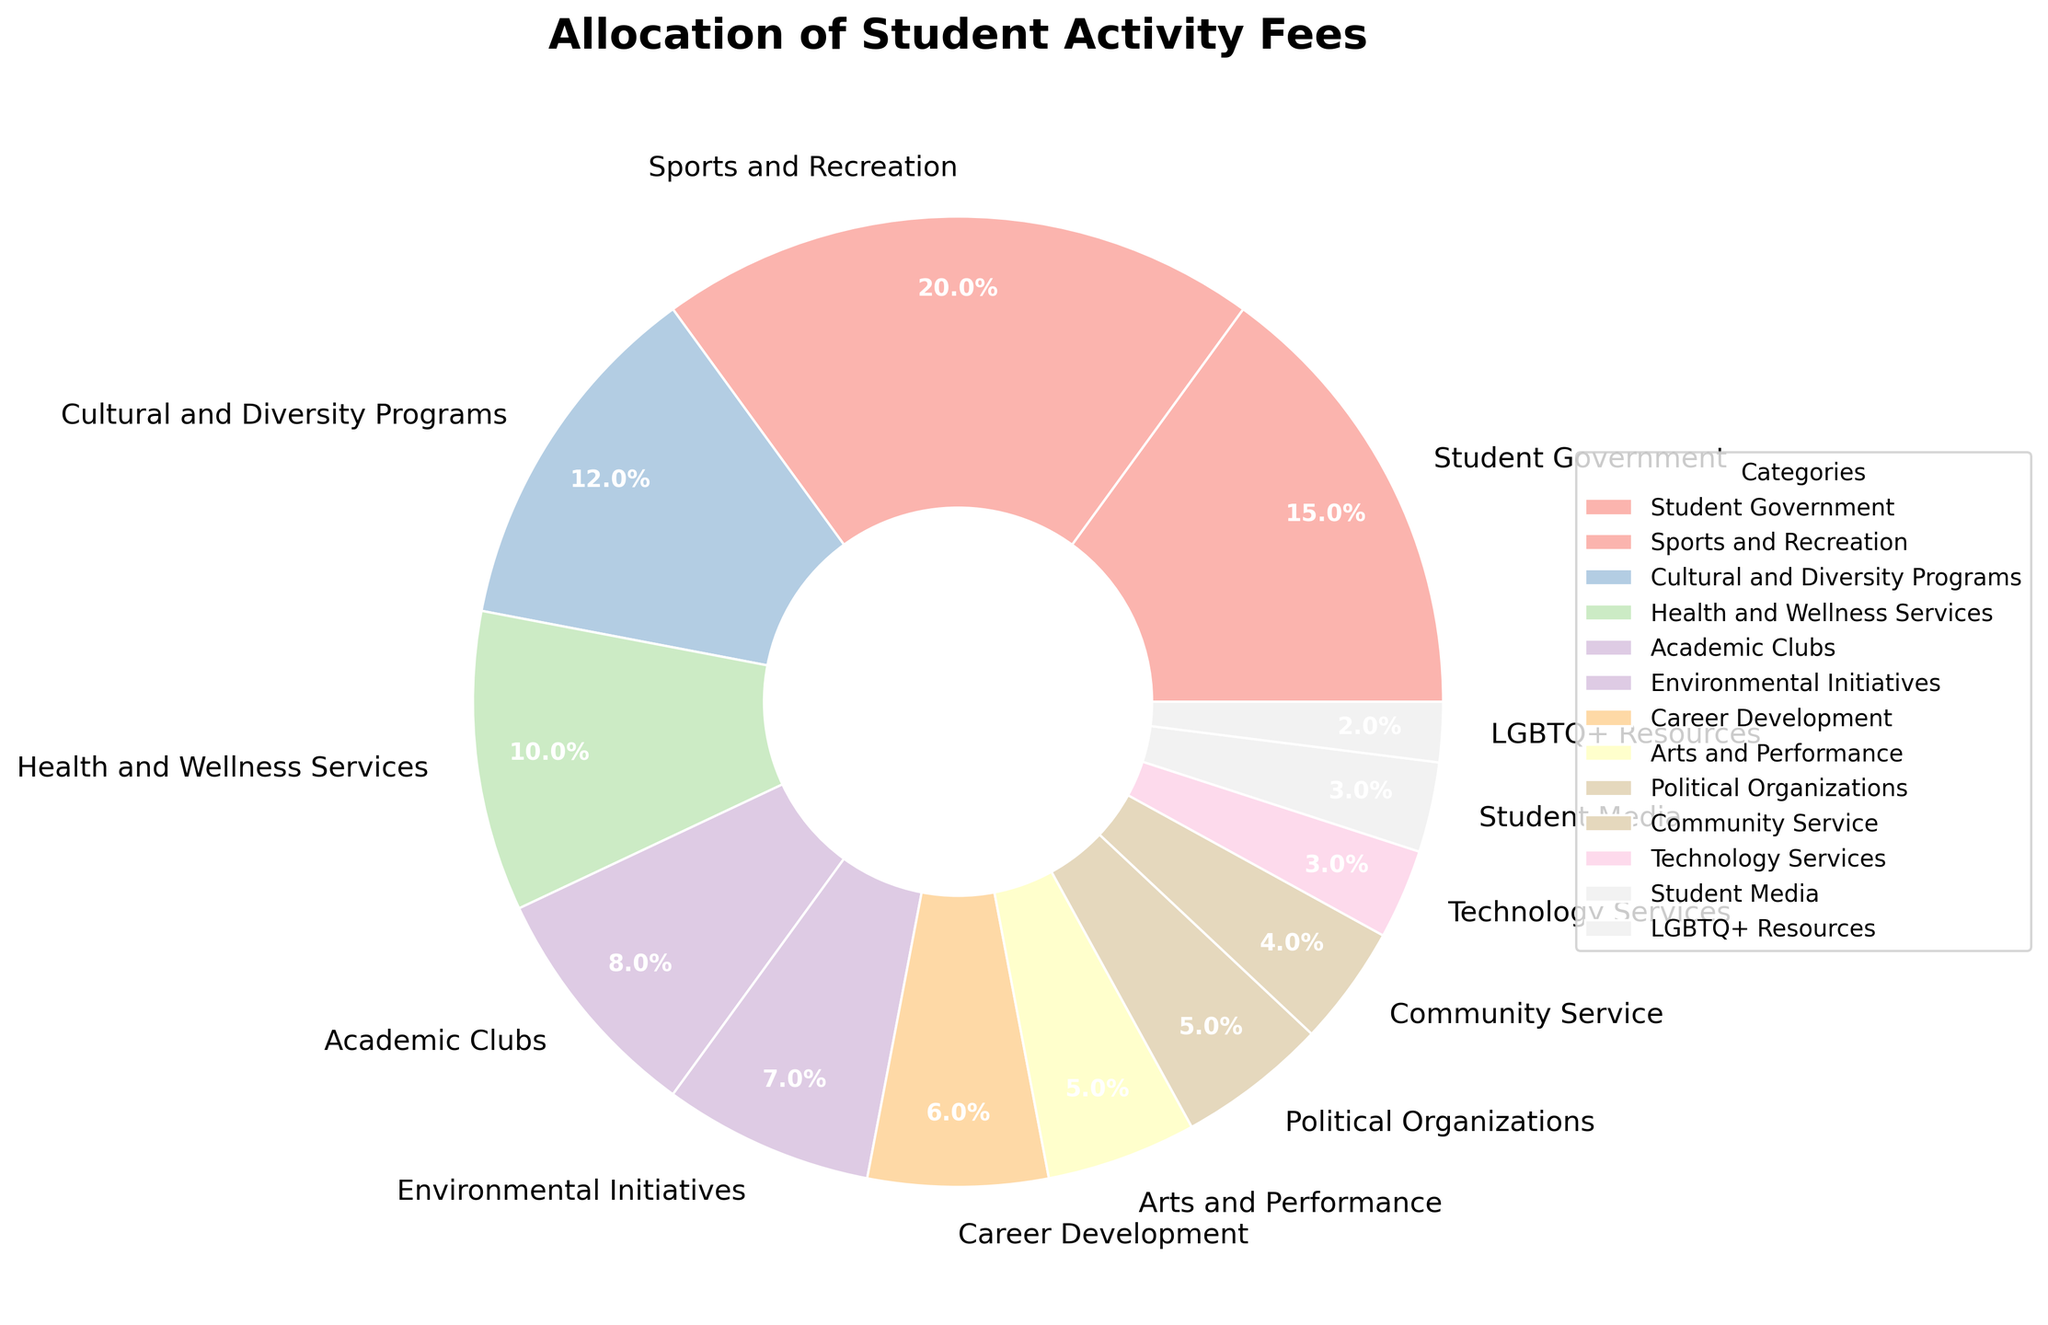Which category receives the highest percentage of student activity fees? The figure shows a pie chart with various categories and their respective percentages. The largest segment belongs to "Sports and Recreation" with 20%.
Answer: Sports and Recreation What is the total percentage allocated to Academic Clubs and Environmental Initiatives combined? To find the combined percentage, add the percentage values from both categories: Academic Clubs (8%) + Environmental Initiatives (7%) = 15%.
Answer: 15% How does the allocation for Political Organizations compare to that for Career Development? The pie chart shows Political Organizations at 5% and Career Development at 6%. Hence, Career Development receives a higher percentage by 1%.
Answer: Career Development is higher Which category has the smallest allocation, and what is its percentage? The smallest segment in the pie chart belongs to "LGBTQ+ Resources" with 2%.
Answer: LGBTQ+ Resources, 2% What is the difference in percentage between Sports and Recreation and Arts and Performance? Subtract the percentage for Arts and Performance (5%) from that for Sports and Recreation (20%): 20% - 5% = 15%.
Answer: 15% What percentage of the student activity fees is allocated to categories related to student welfare services (Health and Wellness Services + LGBTQ+ Resources)? Sum the percentages: Health and Wellness Services (10%) + LGBTQ+ Resources (2%) = 12%.
Answer: 12% Which categories have an equal allocation percentage? From the pie chart, Arts and Performance and Political Organizations both have an allocation of 5%.
Answer: Arts and Performance and Political Organizations What is the combined percentage of categories receiving less than 5% of the student activity fees? Add the percentages of Community Service (4%), Technology Services (3%), Student Media (3%), and LGBTQ+ Resources (2%): 4% + 3% + 3% + 2% = 12%.
Answer: 12% If the student's activity fee is increased by 50% and allocations remain the same, what would be the new percentage for Career Development? The percentage allocation for each category remains unchanged regardless of the increase in the total amount. Career Development's allocation stays at 6%.
Answer: 6% 